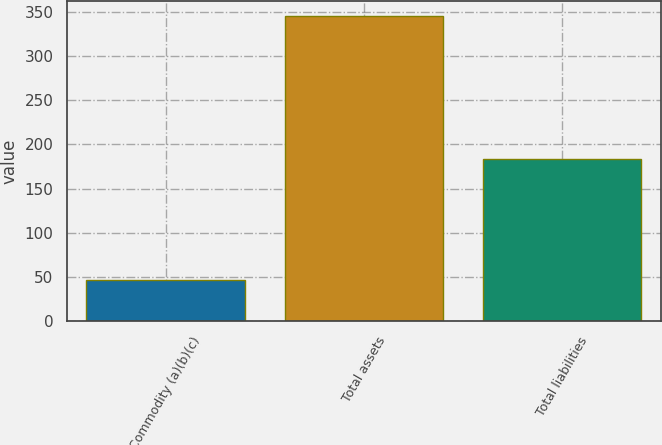<chart> <loc_0><loc_0><loc_500><loc_500><bar_chart><fcel>Commodity (a)(b)(c)<fcel>Total assets<fcel>Total liabilities<nl><fcel>47<fcel>345<fcel>183<nl></chart> 